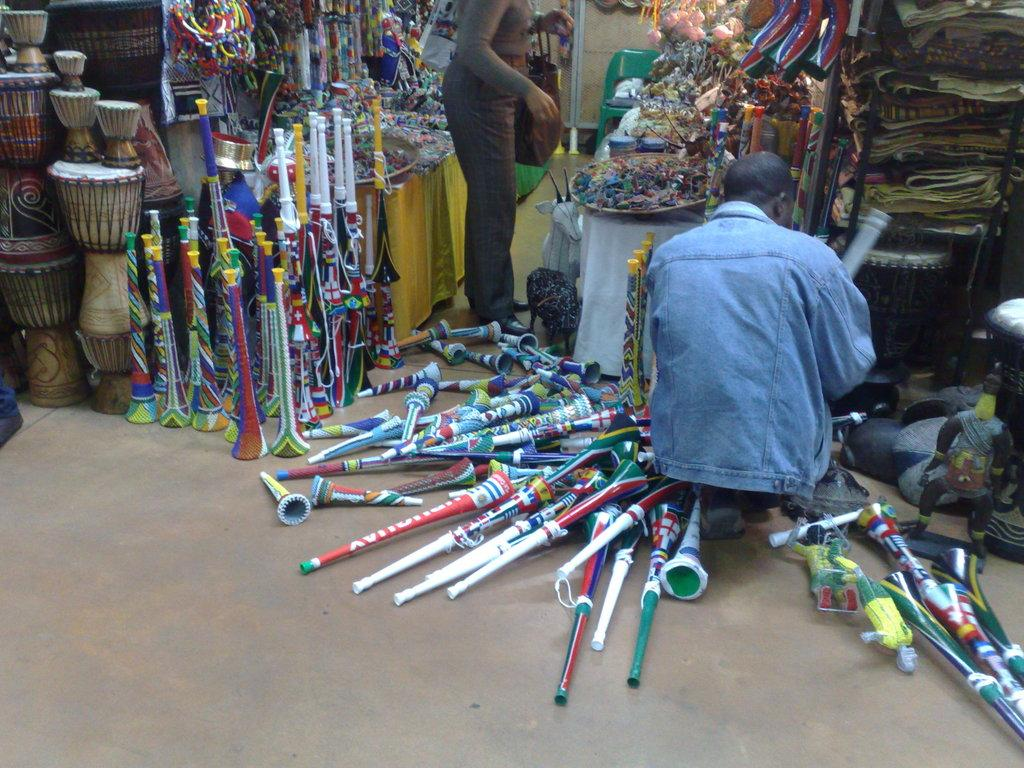How many people are in the image? There are people in the image, but the exact number is not specified. What is one person holding in the image? One person is holding a bag in the image. Can you describe the decor visible in the image? There is decor visible in the image, but the specifics are not mentioned. What type of toys are in the image? There are toys in the image, but the specific types are not specified. What are the racks used for in the image? The racks are used for holding or displaying objects in the image, but their exact purpose is not mentioned. What is at the bottom of the image? There is a floor at the bottom of the image. What type of music can be heard playing in the background of the image? There is no mention of music or any sound in the image, so it cannot be determined from the image. 